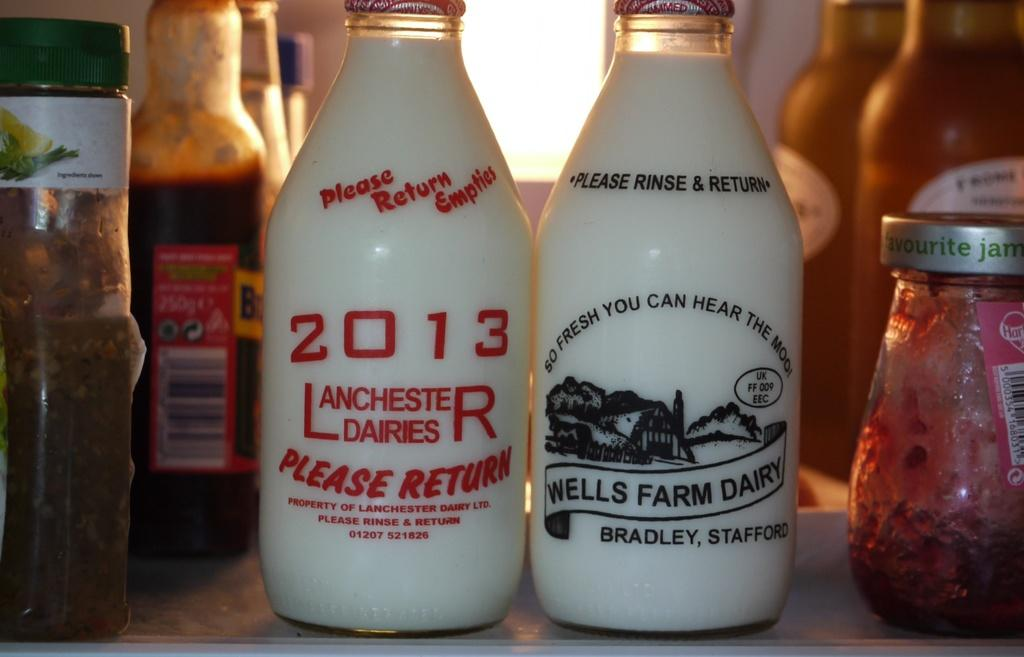What type of containers can be seen in the image? There are bottles and a jar in the image. Can you describe the appearance of the containers? The containers are bottles and a jar, but their specific appearance cannot be determined from the provided facts. What time of day is depicted in the image? The provided facts do not mention the time of day, so it cannot be determined from the image. What type of ear is visible in the image? There is no ear present in the image. Is there a chain connecting the bottles in the image? The provided facts do not mention a chain, so it cannot be determined from the image. 